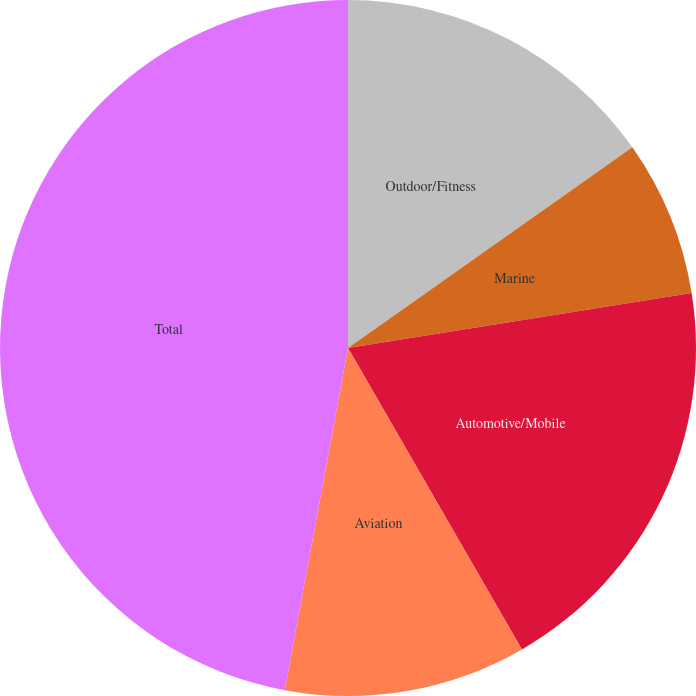Convert chart to OTSL. <chart><loc_0><loc_0><loc_500><loc_500><pie_chart><fcel>Outdoor/Fitness<fcel>Marine<fcel>Automotive/Mobile<fcel>Aviation<fcel>Total<nl><fcel>15.22%<fcel>7.25%<fcel>19.2%<fcel>11.24%<fcel>47.09%<nl></chart> 